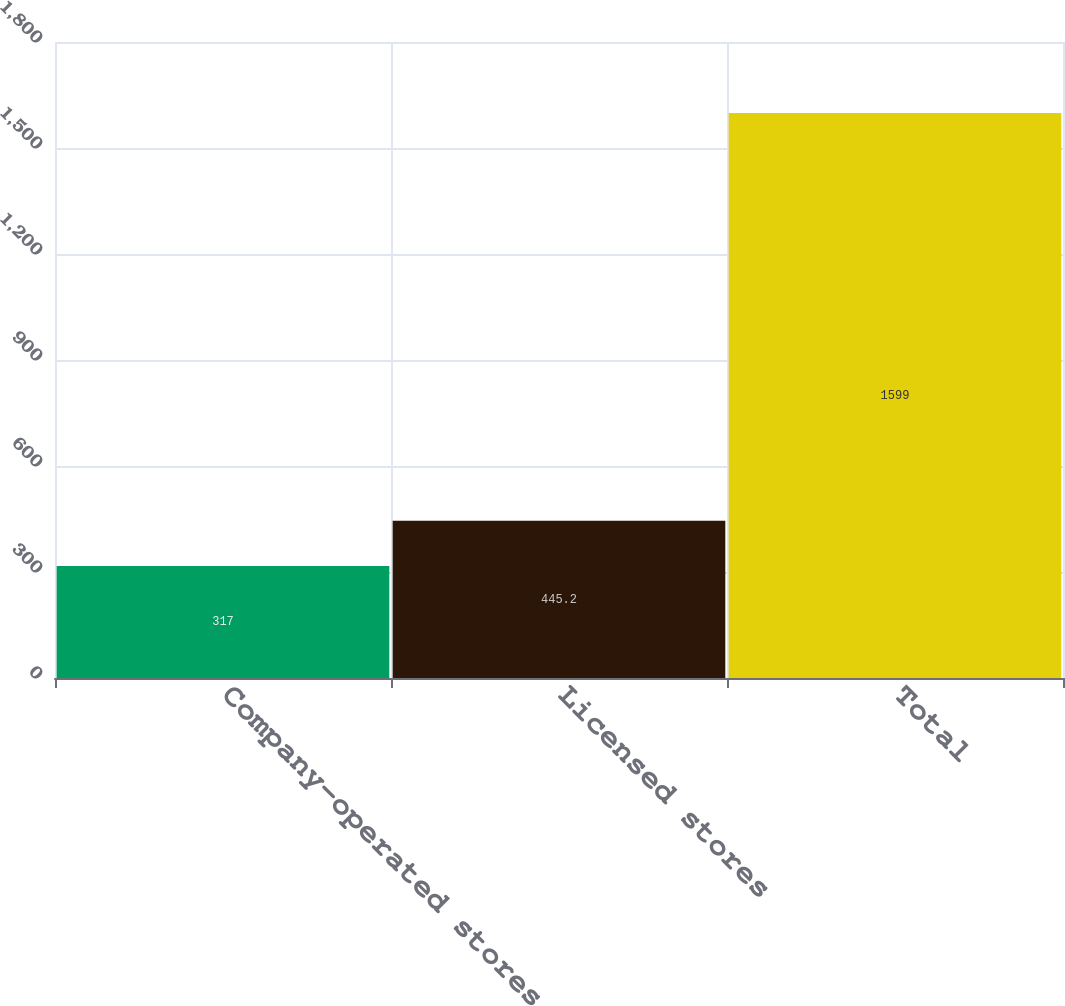<chart> <loc_0><loc_0><loc_500><loc_500><bar_chart><fcel>Company-operated stores<fcel>Licensed stores<fcel>Total<nl><fcel>317<fcel>445.2<fcel>1599<nl></chart> 